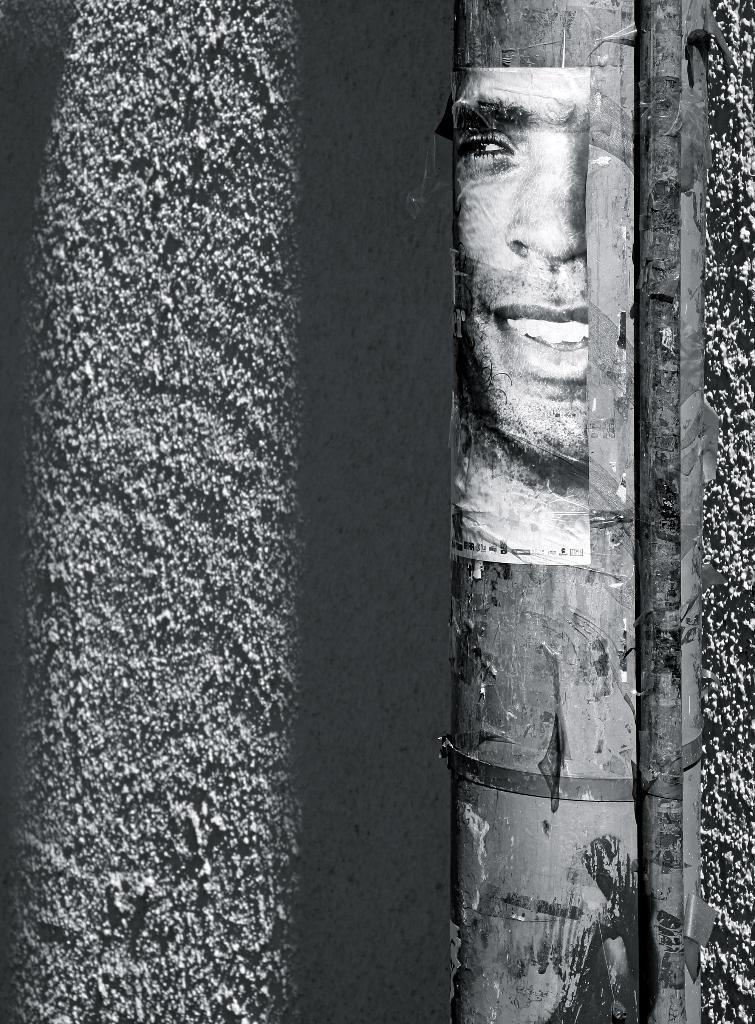Can you describe this image briefly? This is a black and white picture. In this there is a wall. On the wall there is a pipe. On the pipe there is a poster of a person smiling. 